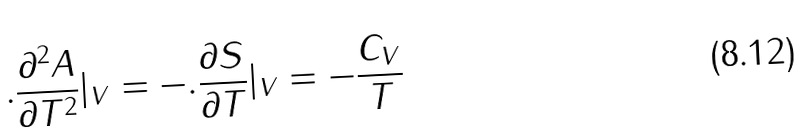Convert formula to latex. <formula><loc_0><loc_0><loc_500><loc_500>. \frac { \partial ^ { 2 } A } { \partial T ^ { 2 } } | _ { V } = - . \frac { \partial S } { \partial T } | _ { V } = - \frac { C _ { V } } { T }</formula> 